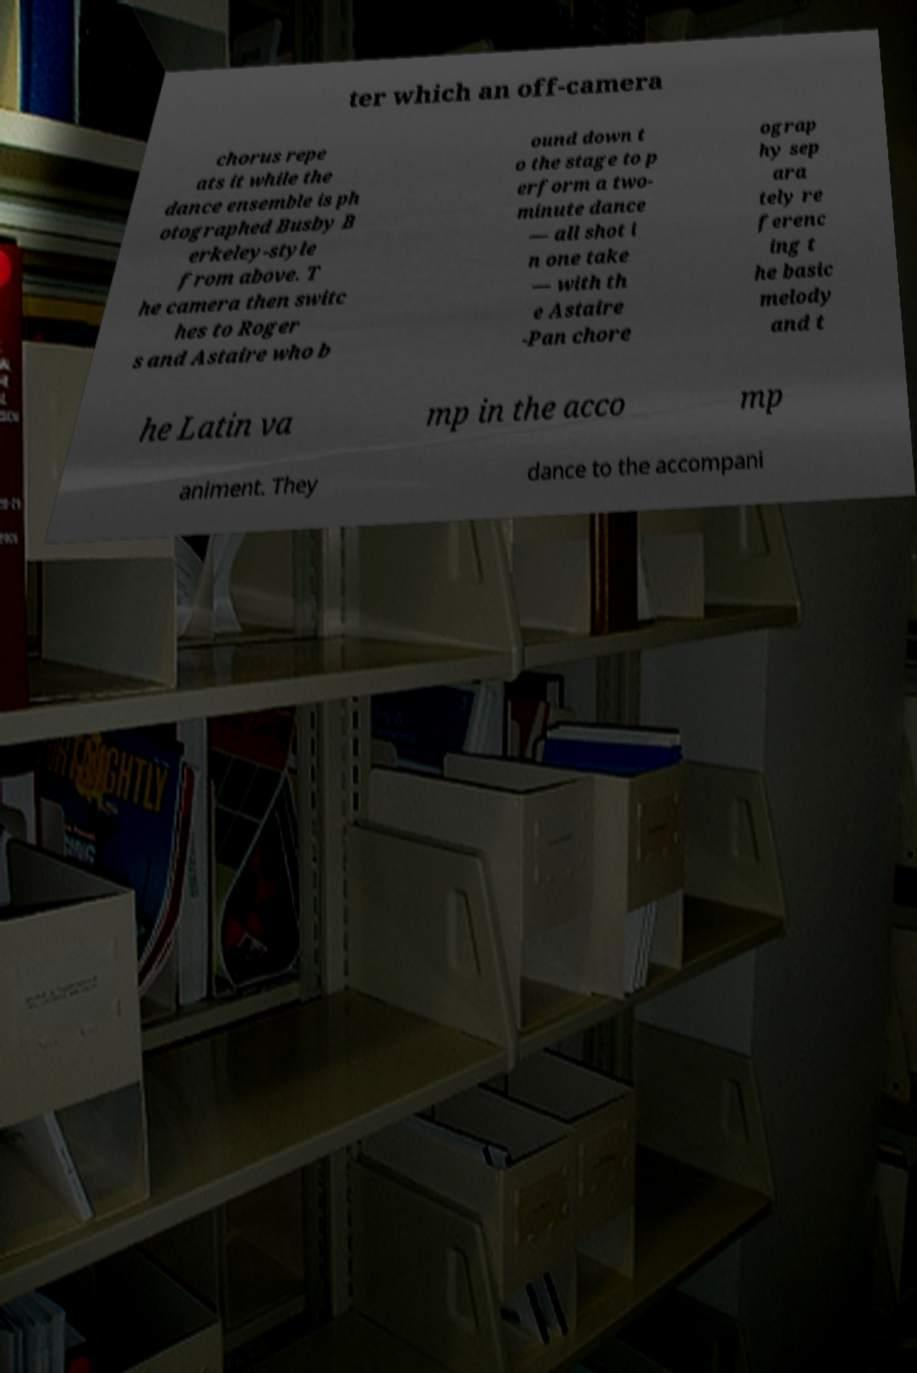Could you assist in decoding the text presented in this image and type it out clearly? ter which an off-camera chorus repe ats it while the dance ensemble is ph otographed Busby B erkeley-style from above. T he camera then switc hes to Roger s and Astaire who b ound down t o the stage to p erform a two- minute dance — all shot i n one take — with th e Astaire -Pan chore ograp hy sep ara tely re ferenc ing t he basic melody and t he Latin va mp in the acco mp animent. They dance to the accompani 